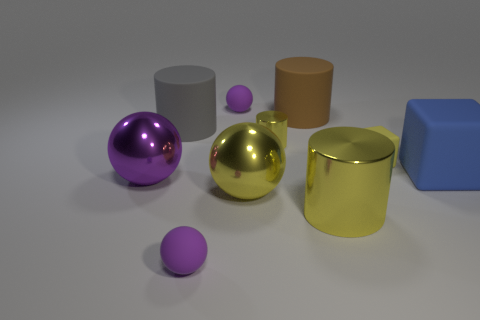What number of things are either small yellow matte blocks or tiny shiny cylinders?
Provide a succinct answer. 2. Do the blue matte object and the matte cylinder in front of the brown cylinder have the same size?
Offer a very short reply. Yes. There is a cylinder that is to the left of the purple sphere to the right of the small purple thing in front of the brown cylinder; what is its size?
Your answer should be very brief. Large. Is there a big purple metal object?
Your answer should be compact. Yes. What material is the block that is the same color as the small metal object?
Your response must be concise. Rubber. How many small things have the same color as the large metal cylinder?
Give a very brief answer. 2. What number of objects are either purple rubber balls in front of the yellow block or purple matte things in front of the big gray cylinder?
Give a very brief answer. 1. There is a small purple matte thing in front of the big metal cylinder; how many metallic balls are to the left of it?
Ensure brevity in your answer.  1. There is another large cylinder that is made of the same material as the brown cylinder; what is its color?
Your answer should be very brief. Gray. Are there any other yellow balls that have the same size as the yellow ball?
Keep it short and to the point. No. 